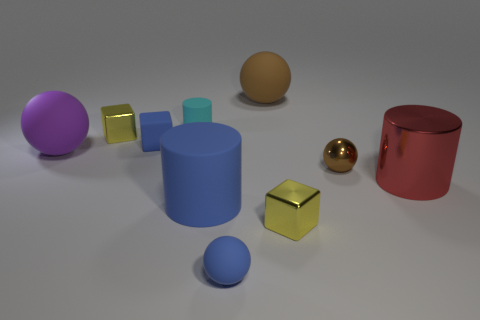Subtract all blue spheres. How many spheres are left? 3 Subtract all gray cylinders. How many brown spheres are left? 2 Subtract all blue spheres. How many spheres are left? 3 Subtract 2 balls. How many balls are left? 2 Subtract all spheres. How many objects are left? 6 Subtract 0 gray cubes. How many objects are left? 10 Subtract all green blocks. Subtract all red balls. How many blocks are left? 3 Subtract all small brown cylinders. Subtract all small cyan rubber things. How many objects are left? 9 Add 9 large brown rubber balls. How many large brown rubber balls are left? 10 Add 6 green blocks. How many green blocks exist? 6 